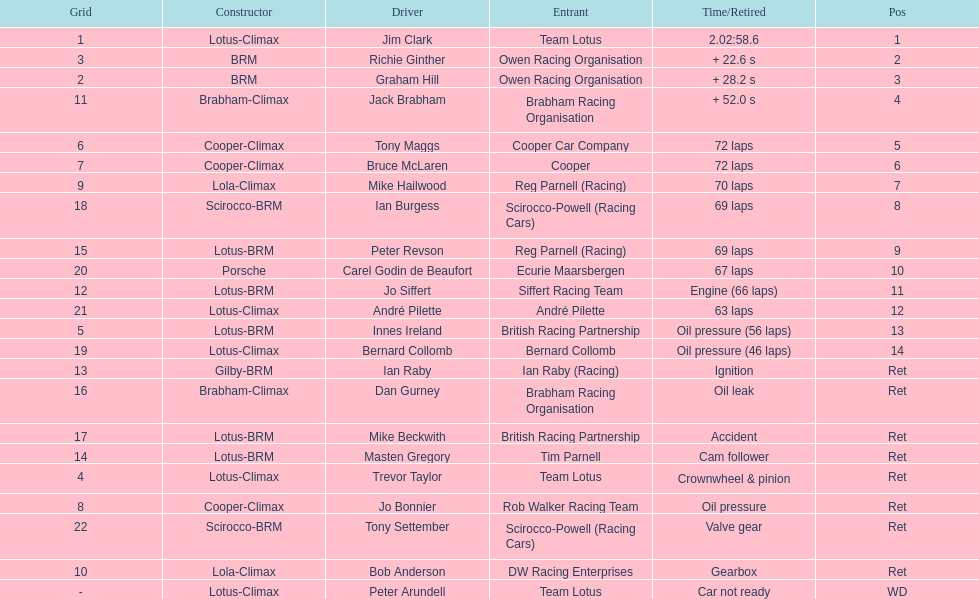Who came in earlier, tony maggs or jo siffert? Tony Maggs. 